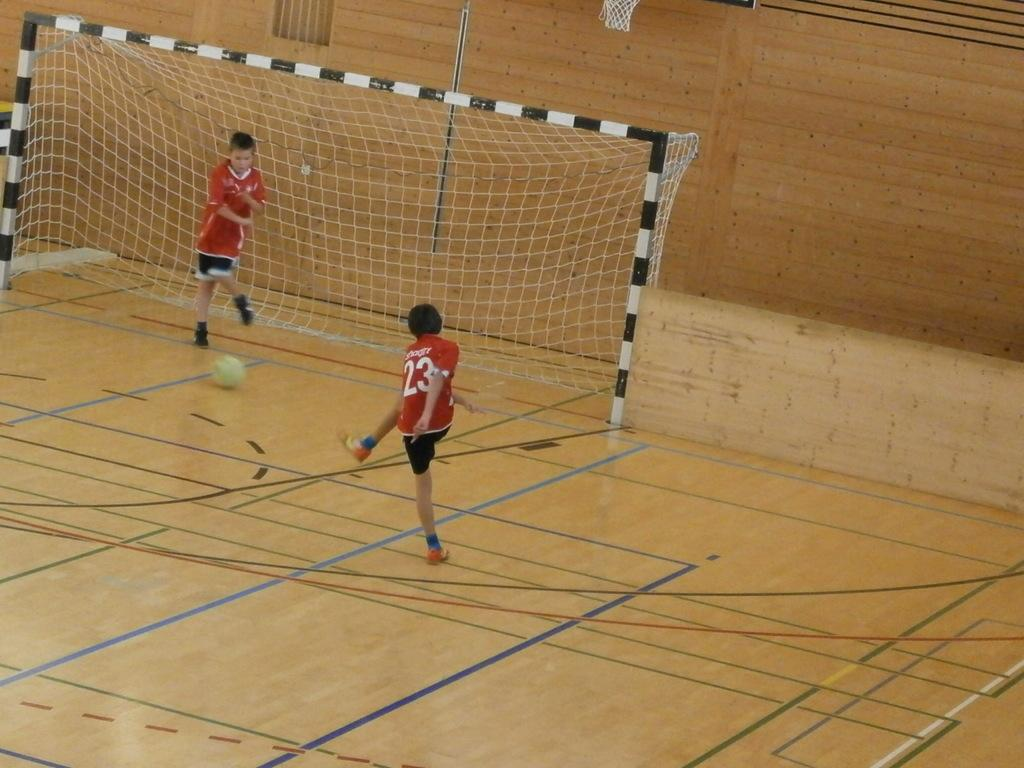<image>
Offer a succinct explanation of the picture presented. A soccer player with number "23" jersey is trying to get the ball to the goal. 